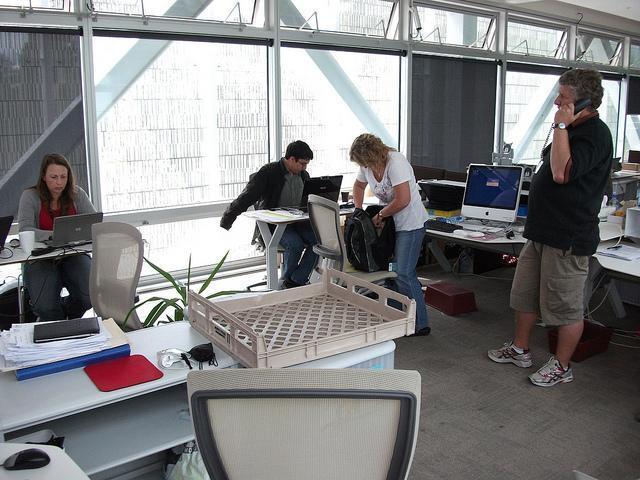How many girls are there?
Give a very brief answer. 2. How many chairs are in the photo?
Give a very brief answer. 3. How many people are there?
Give a very brief answer. 4. 